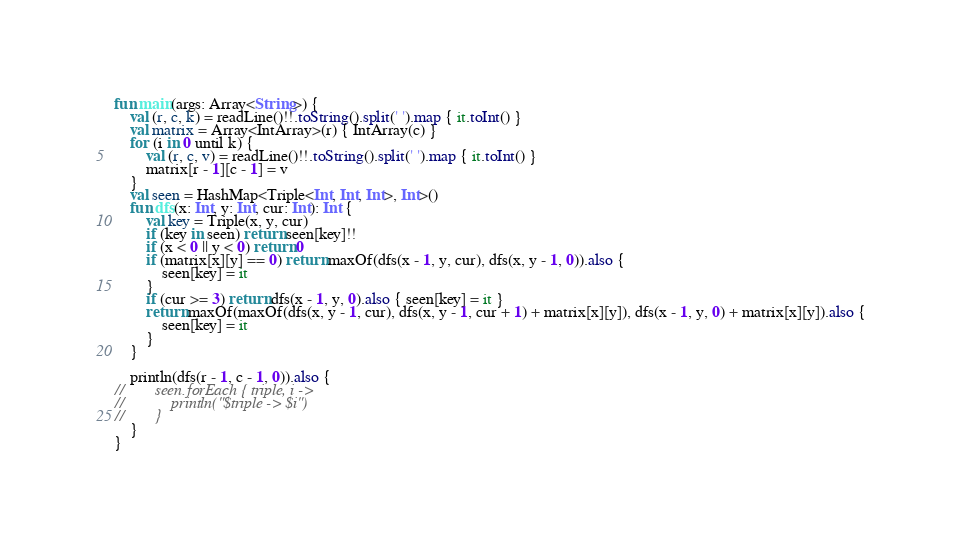<code> <loc_0><loc_0><loc_500><loc_500><_Kotlin_>fun main(args: Array<String>) {
    val (r, c, k) = readLine()!!.toString().split(' ').map { it.toInt() }
    val matrix = Array<IntArray>(r) { IntArray(c) }
    for (i in 0 until k) {
        val (r, c, v) = readLine()!!.toString().split(' ').map { it.toInt() }
        matrix[r - 1][c - 1] = v
    }
    val seen = HashMap<Triple<Int, Int, Int>, Int>()
    fun dfs(x: Int, y: Int, cur: Int): Int {
        val key = Triple(x, y, cur)
        if (key in seen) return seen[key]!!
        if (x < 0 || y < 0) return 0
        if (matrix[x][y] == 0) return maxOf(dfs(x - 1, y, cur), dfs(x, y - 1, 0)).also {
            seen[key] = it
        }
        if (cur >= 3) return dfs(x - 1, y, 0).also { seen[key] = it }
        return maxOf(maxOf(dfs(x, y - 1, cur), dfs(x, y - 1, cur + 1) + matrix[x][y]), dfs(x - 1, y, 0) + matrix[x][y]).also {
            seen[key] = it
        }
    }

    println(dfs(r - 1, c - 1, 0)).also {
//        seen.forEach { triple, i ->
//            println("$triple -> $i")
//        }
    }
}</code> 